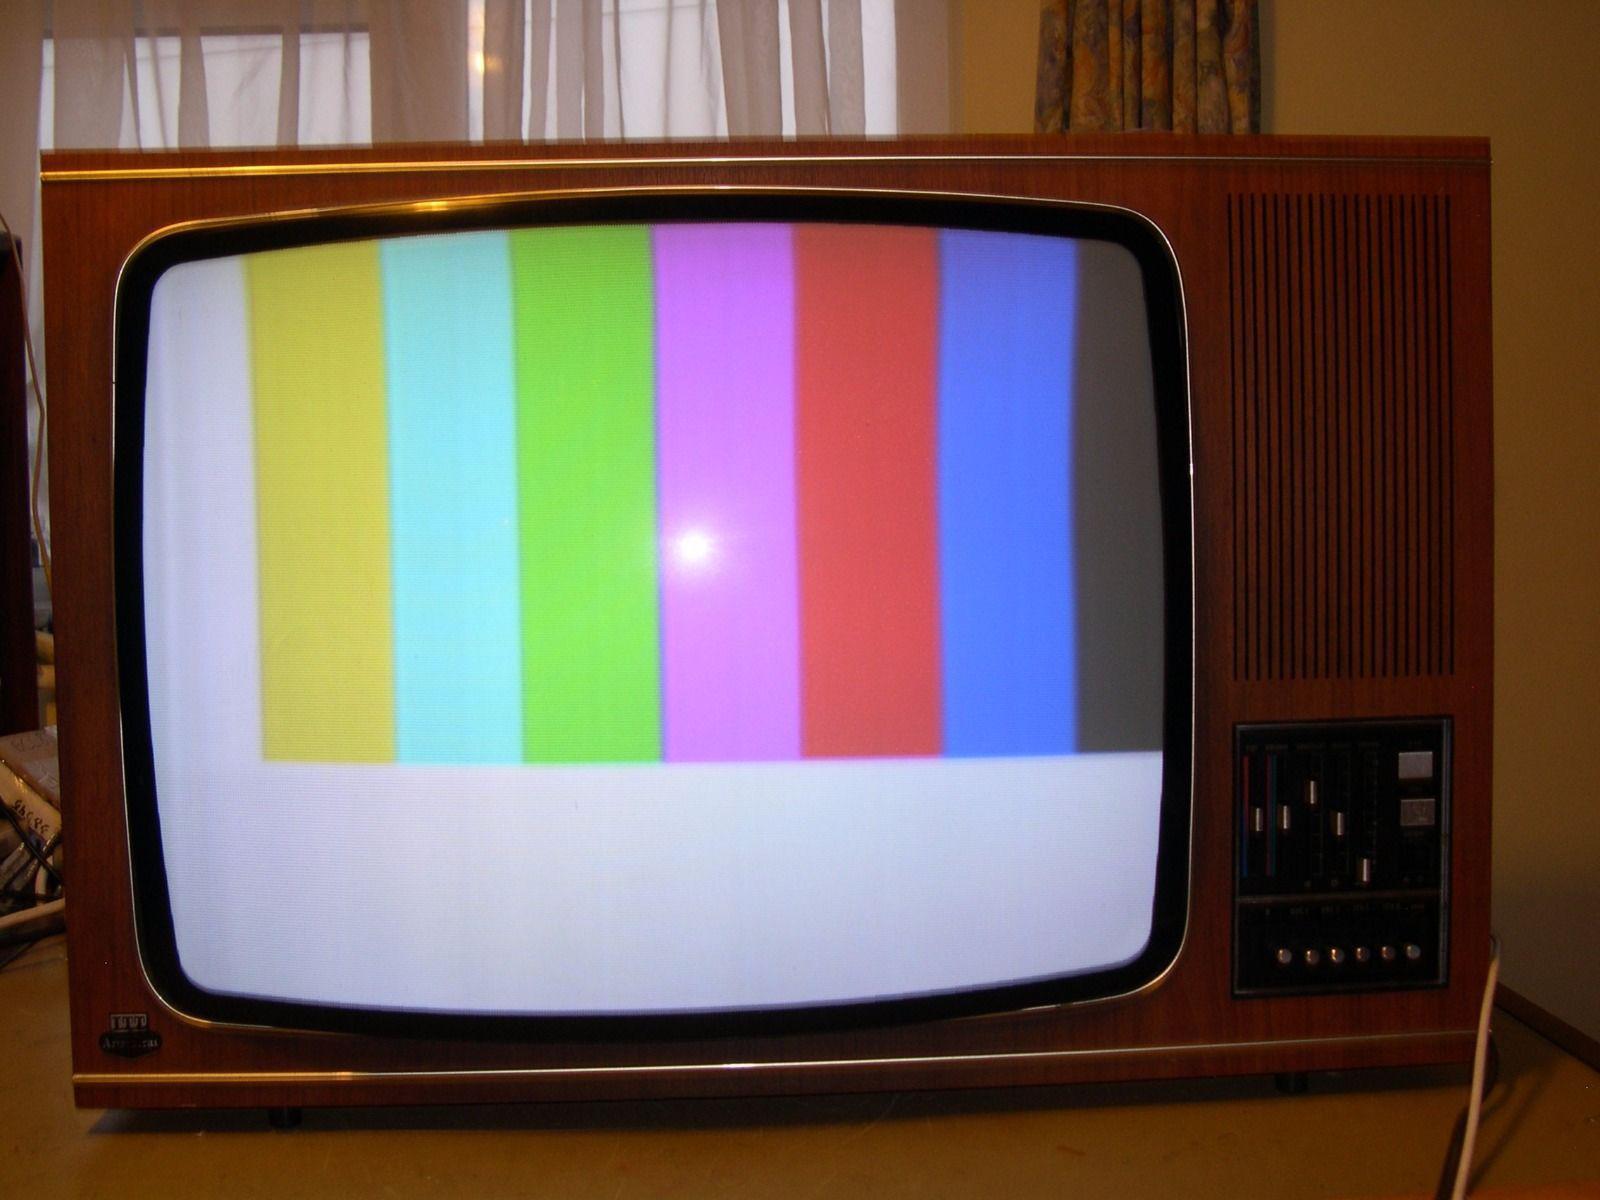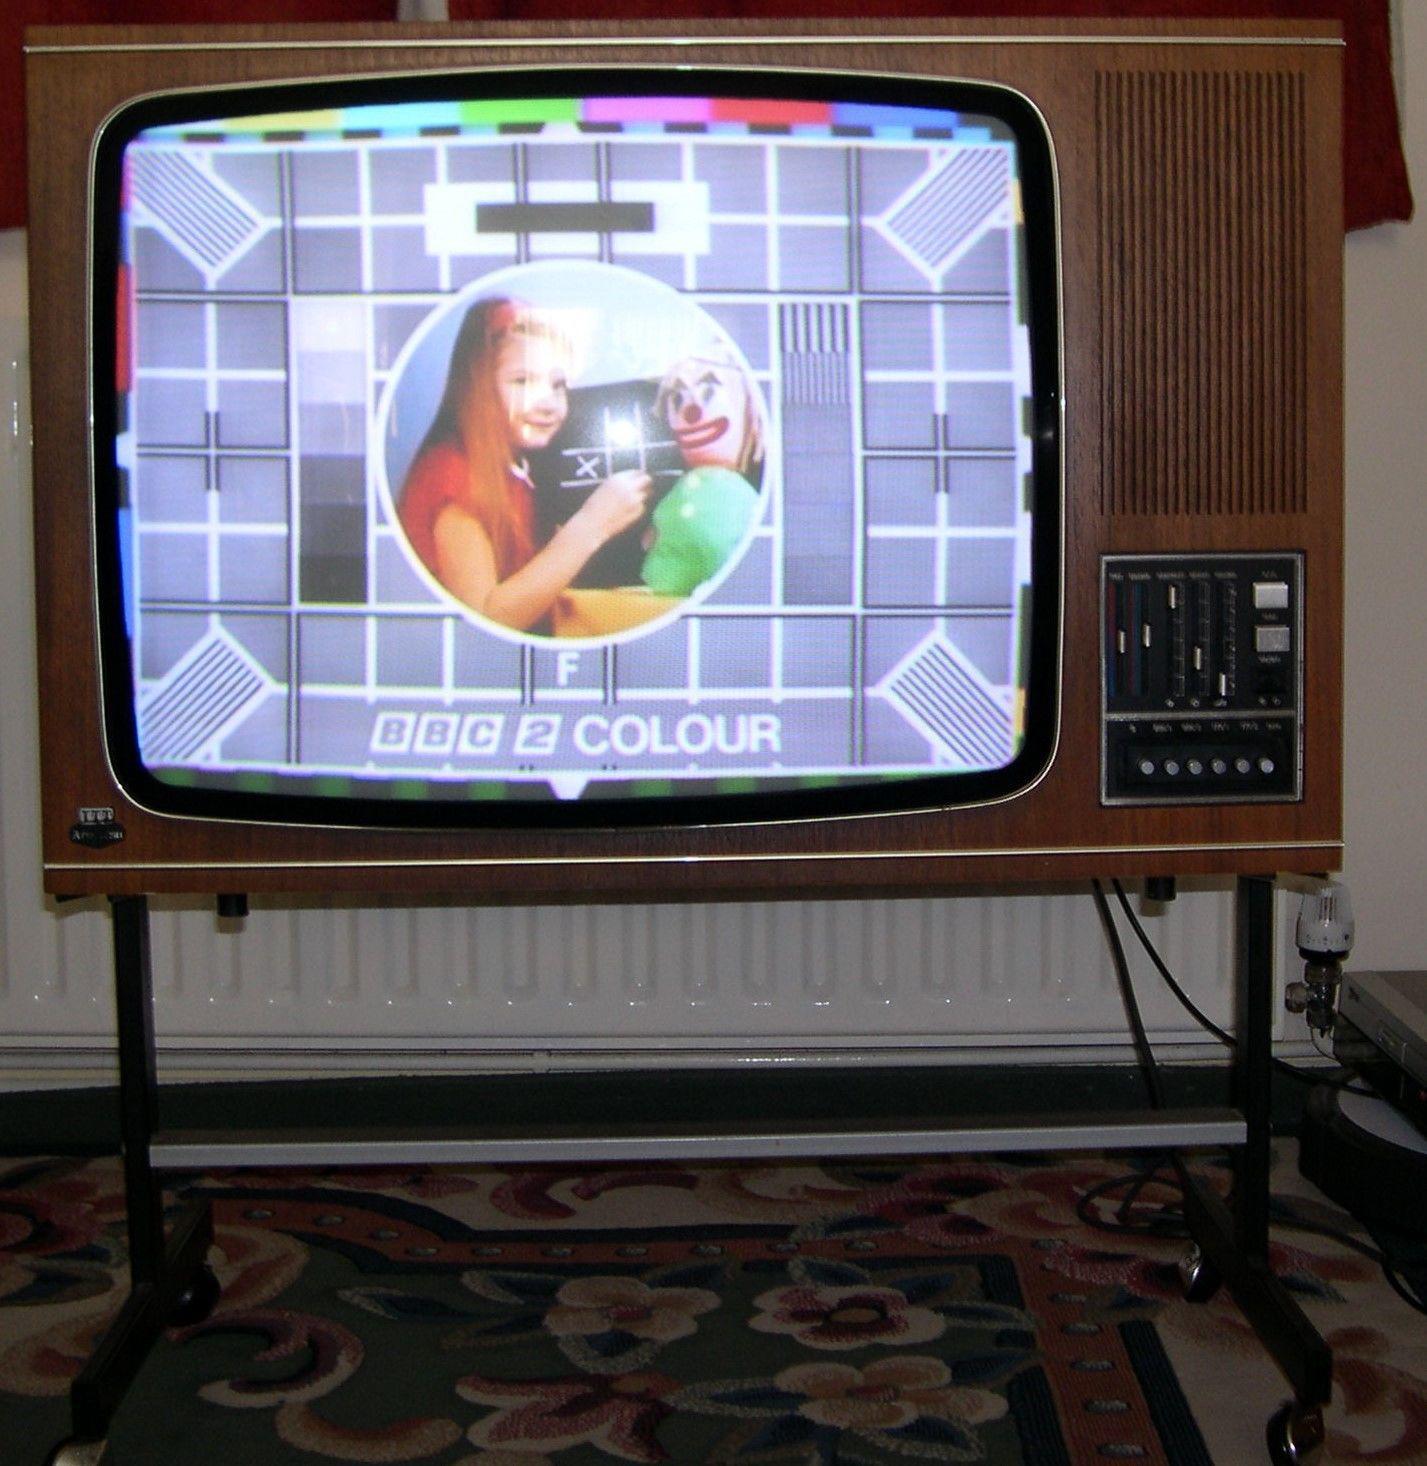The first image is the image on the left, the second image is the image on the right. Analyze the images presented: Is the assertion "An image shows a TV screen displaying a pattern of squares with a circle in the center." valid? Answer yes or no. Yes. The first image is the image on the left, the second image is the image on the right. For the images shown, is this caption "One television set is a table top model, while the other is standing on legs, but both have a control and speaker area to the side of the picture tube." true? Answer yes or no. Yes. 